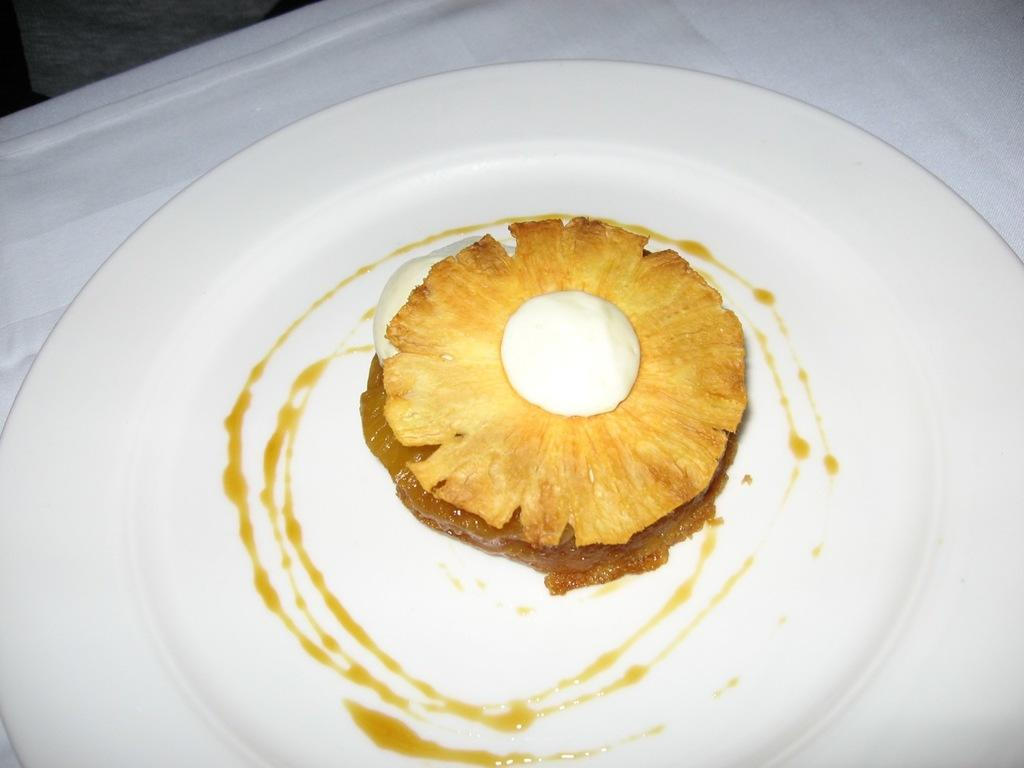What is the main piece of furniture in the picture? There is a table in the picture. What is placed on the table? There is a plate with a food item on the table. Where is the coat hanging in the picture? There is no coat present in the image. Can you see a kitty playing with a clover in the picture? There is no kitty or clover present in the image. 